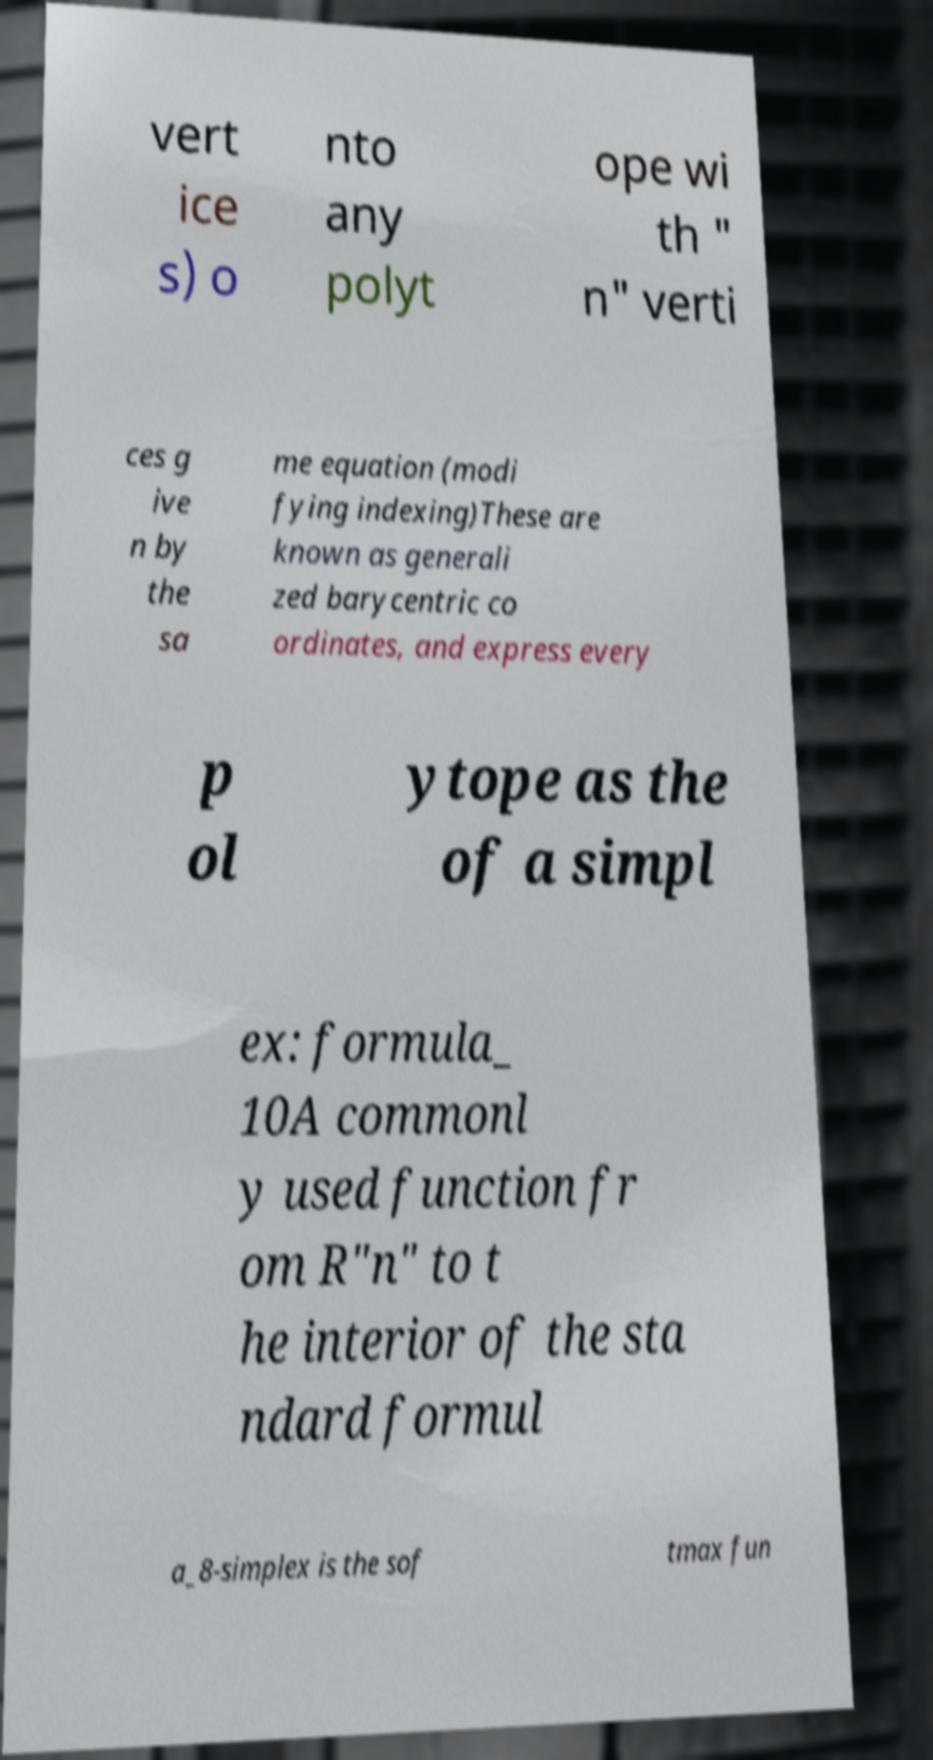What messages or text are displayed in this image? I need them in a readable, typed format. vert ice s) o nto any polyt ope wi th " n" verti ces g ive n by the sa me equation (modi fying indexing)These are known as generali zed barycentric co ordinates, and express every p ol ytope as the of a simpl ex: formula_ 10A commonl y used function fr om R"n" to t he interior of the sta ndard formul a_8-simplex is the sof tmax fun 